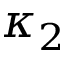<formula> <loc_0><loc_0><loc_500><loc_500>\kappa _ { 2 }</formula> 